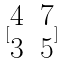<formula> <loc_0><loc_0><loc_500><loc_500>[ \begin{matrix} 4 & 7 \\ 3 & 5 \end{matrix} ]</formula> 